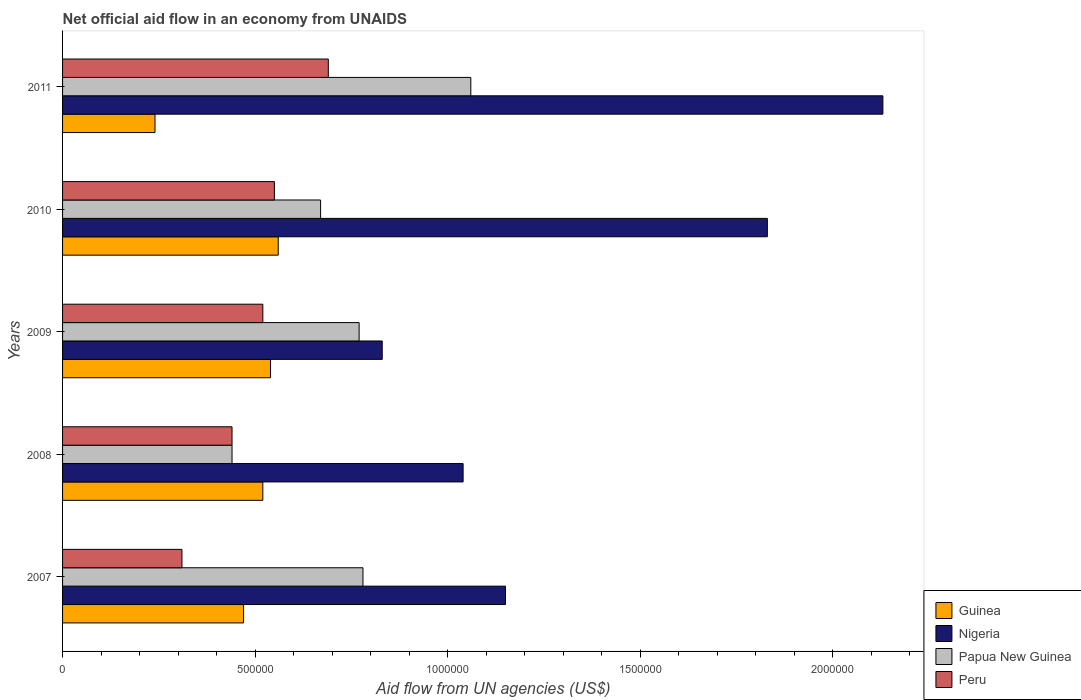How many different coloured bars are there?
Offer a terse response. 4. How many groups of bars are there?
Give a very brief answer. 5. How many bars are there on the 2nd tick from the top?
Provide a succinct answer. 4. In how many cases, is the number of bars for a given year not equal to the number of legend labels?
Provide a succinct answer. 0. What is the net official aid flow in Papua New Guinea in 2009?
Your answer should be very brief. 7.70e+05. Across all years, what is the maximum net official aid flow in Papua New Guinea?
Ensure brevity in your answer.  1.06e+06. Across all years, what is the minimum net official aid flow in Nigeria?
Your answer should be very brief. 8.30e+05. In which year was the net official aid flow in Peru maximum?
Offer a terse response. 2011. What is the total net official aid flow in Nigeria in the graph?
Give a very brief answer. 6.98e+06. What is the difference between the net official aid flow in Papua New Guinea in 2008 and that in 2010?
Provide a short and direct response. -2.30e+05. What is the difference between the net official aid flow in Nigeria in 2010 and the net official aid flow in Peru in 2011?
Keep it short and to the point. 1.14e+06. What is the average net official aid flow in Guinea per year?
Your answer should be compact. 4.66e+05. In the year 2008, what is the difference between the net official aid flow in Papua New Guinea and net official aid flow in Guinea?
Provide a short and direct response. -8.00e+04. In how many years, is the net official aid flow in Guinea greater than 200000 US$?
Your response must be concise. 5. What is the ratio of the net official aid flow in Papua New Guinea in 2008 to that in 2009?
Ensure brevity in your answer.  0.57. Is the net official aid flow in Peru in 2007 less than that in 2009?
Provide a short and direct response. Yes. Is the difference between the net official aid flow in Papua New Guinea in 2007 and 2010 greater than the difference between the net official aid flow in Guinea in 2007 and 2010?
Your response must be concise. Yes. What is the difference between the highest and the second highest net official aid flow in Guinea?
Provide a short and direct response. 2.00e+04. What is the difference between the highest and the lowest net official aid flow in Guinea?
Your answer should be compact. 3.20e+05. Is the sum of the net official aid flow in Nigeria in 2009 and 2011 greater than the maximum net official aid flow in Peru across all years?
Make the answer very short. Yes. What does the 4th bar from the top in 2009 represents?
Ensure brevity in your answer.  Guinea. What does the 2nd bar from the bottom in 2010 represents?
Your answer should be very brief. Nigeria. Is it the case that in every year, the sum of the net official aid flow in Guinea and net official aid flow in Peru is greater than the net official aid flow in Nigeria?
Your answer should be compact. No. How many bars are there?
Give a very brief answer. 20. Are all the bars in the graph horizontal?
Your response must be concise. Yes. What is the difference between two consecutive major ticks on the X-axis?
Provide a succinct answer. 5.00e+05. Where does the legend appear in the graph?
Your answer should be compact. Bottom right. How many legend labels are there?
Ensure brevity in your answer.  4. What is the title of the graph?
Offer a very short reply. Net official aid flow in an economy from UNAIDS. Does "Syrian Arab Republic" appear as one of the legend labels in the graph?
Offer a terse response. No. What is the label or title of the X-axis?
Make the answer very short. Aid flow from UN agencies (US$). What is the label or title of the Y-axis?
Give a very brief answer. Years. What is the Aid flow from UN agencies (US$) in Nigeria in 2007?
Keep it short and to the point. 1.15e+06. What is the Aid flow from UN agencies (US$) of Papua New Guinea in 2007?
Make the answer very short. 7.80e+05. What is the Aid flow from UN agencies (US$) of Guinea in 2008?
Offer a terse response. 5.20e+05. What is the Aid flow from UN agencies (US$) of Nigeria in 2008?
Your response must be concise. 1.04e+06. What is the Aid flow from UN agencies (US$) in Papua New Guinea in 2008?
Your answer should be very brief. 4.40e+05. What is the Aid flow from UN agencies (US$) of Peru in 2008?
Provide a short and direct response. 4.40e+05. What is the Aid flow from UN agencies (US$) of Guinea in 2009?
Ensure brevity in your answer.  5.40e+05. What is the Aid flow from UN agencies (US$) of Nigeria in 2009?
Offer a terse response. 8.30e+05. What is the Aid flow from UN agencies (US$) in Papua New Guinea in 2009?
Give a very brief answer. 7.70e+05. What is the Aid flow from UN agencies (US$) of Peru in 2009?
Your answer should be compact. 5.20e+05. What is the Aid flow from UN agencies (US$) of Guinea in 2010?
Provide a succinct answer. 5.60e+05. What is the Aid flow from UN agencies (US$) of Nigeria in 2010?
Your response must be concise. 1.83e+06. What is the Aid flow from UN agencies (US$) in Papua New Guinea in 2010?
Make the answer very short. 6.70e+05. What is the Aid flow from UN agencies (US$) of Nigeria in 2011?
Your answer should be compact. 2.13e+06. What is the Aid flow from UN agencies (US$) in Papua New Guinea in 2011?
Your response must be concise. 1.06e+06. What is the Aid flow from UN agencies (US$) in Peru in 2011?
Provide a succinct answer. 6.90e+05. Across all years, what is the maximum Aid flow from UN agencies (US$) in Guinea?
Give a very brief answer. 5.60e+05. Across all years, what is the maximum Aid flow from UN agencies (US$) in Nigeria?
Keep it short and to the point. 2.13e+06. Across all years, what is the maximum Aid flow from UN agencies (US$) in Papua New Guinea?
Your answer should be compact. 1.06e+06. Across all years, what is the maximum Aid flow from UN agencies (US$) in Peru?
Ensure brevity in your answer.  6.90e+05. Across all years, what is the minimum Aid flow from UN agencies (US$) in Guinea?
Offer a very short reply. 2.40e+05. Across all years, what is the minimum Aid flow from UN agencies (US$) of Nigeria?
Give a very brief answer. 8.30e+05. What is the total Aid flow from UN agencies (US$) of Guinea in the graph?
Keep it short and to the point. 2.33e+06. What is the total Aid flow from UN agencies (US$) of Nigeria in the graph?
Give a very brief answer. 6.98e+06. What is the total Aid flow from UN agencies (US$) in Papua New Guinea in the graph?
Make the answer very short. 3.72e+06. What is the total Aid flow from UN agencies (US$) of Peru in the graph?
Offer a terse response. 2.51e+06. What is the difference between the Aid flow from UN agencies (US$) of Nigeria in 2007 and that in 2008?
Keep it short and to the point. 1.10e+05. What is the difference between the Aid flow from UN agencies (US$) in Papua New Guinea in 2007 and that in 2008?
Keep it short and to the point. 3.40e+05. What is the difference between the Aid flow from UN agencies (US$) in Nigeria in 2007 and that in 2009?
Make the answer very short. 3.20e+05. What is the difference between the Aid flow from UN agencies (US$) in Peru in 2007 and that in 2009?
Your response must be concise. -2.10e+05. What is the difference between the Aid flow from UN agencies (US$) in Guinea in 2007 and that in 2010?
Keep it short and to the point. -9.00e+04. What is the difference between the Aid flow from UN agencies (US$) in Nigeria in 2007 and that in 2010?
Offer a very short reply. -6.80e+05. What is the difference between the Aid flow from UN agencies (US$) in Papua New Guinea in 2007 and that in 2010?
Provide a short and direct response. 1.10e+05. What is the difference between the Aid flow from UN agencies (US$) of Nigeria in 2007 and that in 2011?
Your answer should be compact. -9.80e+05. What is the difference between the Aid flow from UN agencies (US$) in Papua New Guinea in 2007 and that in 2011?
Ensure brevity in your answer.  -2.80e+05. What is the difference between the Aid flow from UN agencies (US$) of Peru in 2007 and that in 2011?
Ensure brevity in your answer.  -3.80e+05. What is the difference between the Aid flow from UN agencies (US$) of Guinea in 2008 and that in 2009?
Give a very brief answer. -2.00e+04. What is the difference between the Aid flow from UN agencies (US$) in Nigeria in 2008 and that in 2009?
Provide a succinct answer. 2.10e+05. What is the difference between the Aid flow from UN agencies (US$) in Papua New Guinea in 2008 and that in 2009?
Your answer should be very brief. -3.30e+05. What is the difference between the Aid flow from UN agencies (US$) in Guinea in 2008 and that in 2010?
Provide a short and direct response. -4.00e+04. What is the difference between the Aid flow from UN agencies (US$) in Nigeria in 2008 and that in 2010?
Ensure brevity in your answer.  -7.90e+05. What is the difference between the Aid flow from UN agencies (US$) in Nigeria in 2008 and that in 2011?
Ensure brevity in your answer.  -1.09e+06. What is the difference between the Aid flow from UN agencies (US$) of Papua New Guinea in 2008 and that in 2011?
Provide a succinct answer. -6.20e+05. What is the difference between the Aid flow from UN agencies (US$) of Guinea in 2009 and that in 2010?
Provide a succinct answer. -2.00e+04. What is the difference between the Aid flow from UN agencies (US$) of Nigeria in 2009 and that in 2010?
Your answer should be very brief. -1.00e+06. What is the difference between the Aid flow from UN agencies (US$) of Nigeria in 2009 and that in 2011?
Keep it short and to the point. -1.30e+06. What is the difference between the Aid flow from UN agencies (US$) of Papua New Guinea in 2009 and that in 2011?
Offer a very short reply. -2.90e+05. What is the difference between the Aid flow from UN agencies (US$) of Peru in 2009 and that in 2011?
Keep it short and to the point. -1.70e+05. What is the difference between the Aid flow from UN agencies (US$) in Guinea in 2010 and that in 2011?
Your answer should be very brief. 3.20e+05. What is the difference between the Aid flow from UN agencies (US$) in Papua New Guinea in 2010 and that in 2011?
Offer a terse response. -3.90e+05. What is the difference between the Aid flow from UN agencies (US$) of Guinea in 2007 and the Aid flow from UN agencies (US$) of Nigeria in 2008?
Provide a short and direct response. -5.70e+05. What is the difference between the Aid flow from UN agencies (US$) of Guinea in 2007 and the Aid flow from UN agencies (US$) of Papua New Guinea in 2008?
Provide a short and direct response. 3.00e+04. What is the difference between the Aid flow from UN agencies (US$) of Nigeria in 2007 and the Aid flow from UN agencies (US$) of Papua New Guinea in 2008?
Your answer should be compact. 7.10e+05. What is the difference between the Aid flow from UN agencies (US$) in Nigeria in 2007 and the Aid flow from UN agencies (US$) in Peru in 2008?
Your answer should be very brief. 7.10e+05. What is the difference between the Aid flow from UN agencies (US$) of Guinea in 2007 and the Aid flow from UN agencies (US$) of Nigeria in 2009?
Ensure brevity in your answer.  -3.60e+05. What is the difference between the Aid flow from UN agencies (US$) of Guinea in 2007 and the Aid flow from UN agencies (US$) of Papua New Guinea in 2009?
Give a very brief answer. -3.00e+05. What is the difference between the Aid flow from UN agencies (US$) of Guinea in 2007 and the Aid flow from UN agencies (US$) of Peru in 2009?
Make the answer very short. -5.00e+04. What is the difference between the Aid flow from UN agencies (US$) in Nigeria in 2007 and the Aid flow from UN agencies (US$) in Papua New Guinea in 2009?
Offer a very short reply. 3.80e+05. What is the difference between the Aid flow from UN agencies (US$) of Nigeria in 2007 and the Aid flow from UN agencies (US$) of Peru in 2009?
Give a very brief answer. 6.30e+05. What is the difference between the Aid flow from UN agencies (US$) in Guinea in 2007 and the Aid flow from UN agencies (US$) in Nigeria in 2010?
Offer a very short reply. -1.36e+06. What is the difference between the Aid flow from UN agencies (US$) in Guinea in 2007 and the Aid flow from UN agencies (US$) in Peru in 2010?
Keep it short and to the point. -8.00e+04. What is the difference between the Aid flow from UN agencies (US$) in Nigeria in 2007 and the Aid flow from UN agencies (US$) in Peru in 2010?
Give a very brief answer. 6.00e+05. What is the difference between the Aid flow from UN agencies (US$) of Guinea in 2007 and the Aid flow from UN agencies (US$) of Nigeria in 2011?
Your answer should be very brief. -1.66e+06. What is the difference between the Aid flow from UN agencies (US$) of Guinea in 2007 and the Aid flow from UN agencies (US$) of Papua New Guinea in 2011?
Ensure brevity in your answer.  -5.90e+05. What is the difference between the Aid flow from UN agencies (US$) of Guinea in 2007 and the Aid flow from UN agencies (US$) of Peru in 2011?
Give a very brief answer. -2.20e+05. What is the difference between the Aid flow from UN agencies (US$) in Guinea in 2008 and the Aid flow from UN agencies (US$) in Nigeria in 2009?
Keep it short and to the point. -3.10e+05. What is the difference between the Aid flow from UN agencies (US$) of Nigeria in 2008 and the Aid flow from UN agencies (US$) of Peru in 2009?
Give a very brief answer. 5.20e+05. What is the difference between the Aid flow from UN agencies (US$) in Papua New Guinea in 2008 and the Aid flow from UN agencies (US$) in Peru in 2009?
Give a very brief answer. -8.00e+04. What is the difference between the Aid flow from UN agencies (US$) of Guinea in 2008 and the Aid flow from UN agencies (US$) of Nigeria in 2010?
Give a very brief answer. -1.31e+06. What is the difference between the Aid flow from UN agencies (US$) of Nigeria in 2008 and the Aid flow from UN agencies (US$) of Peru in 2010?
Offer a very short reply. 4.90e+05. What is the difference between the Aid flow from UN agencies (US$) in Papua New Guinea in 2008 and the Aid flow from UN agencies (US$) in Peru in 2010?
Give a very brief answer. -1.10e+05. What is the difference between the Aid flow from UN agencies (US$) in Guinea in 2008 and the Aid flow from UN agencies (US$) in Nigeria in 2011?
Give a very brief answer. -1.61e+06. What is the difference between the Aid flow from UN agencies (US$) of Guinea in 2008 and the Aid flow from UN agencies (US$) of Papua New Guinea in 2011?
Make the answer very short. -5.40e+05. What is the difference between the Aid flow from UN agencies (US$) in Nigeria in 2008 and the Aid flow from UN agencies (US$) in Papua New Guinea in 2011?
Ensure brevity in your answer.  -2.00e+04. What is the difference between the Aid flow from UN agencies (US$) of Guinea in 2009 and the Aid flow from UN agencies (US$) of Nigeria in 2010?
Provide a short and direct response. -1.29e+06. What is the difference between the Aid flow from UN agencies (US$) in Guinea in 2009 and the Aid flow from UN agencies (US$) in Papua New Guinea in 2010?
Offer a very short reply. -1.30e+05. What is the difference between the Aid flow from UN agencies (US$) of Guinea in 2009 and the Aid flow from UN agencies (US$) of Peru in 2010?
Make the answer very short. -10000. What is the difference between the Aid flow from UN agencies (US$) of Nigeria in 2009 and the Aid flow from UN agencies (US$) of Peru in 2010?
Give a very brief answer. 2.80e+05. What is the difference between the Aid flow from UN agencies (US$) in Guinea in 2009 and the Aid flow from UN agencies (US$) in Nigeria in 2011?
Give a very brief answer. -1.59e+06. What is the difference between the Aid flow from UN agencies (US$) in Guinea in 2009 and the Aid flow from UN agencies (US$) in Papua New Guinea in 2011?
Offer a terse response. -5.20e+05. What is the difference between the Aid flow from UN agencies (US$) in Guinea in 2010 and the Aid flow from UN agencies (US$) in Nigeria in 2011?
Provide a short and direct response. -1.57e+06. What is the difference between the Aid flow from UN agencies (US$) in Guinea in 2010 and the Aid flow from UN agencies (US$) in Papua New Guinea in 2011?
Your answer should be compact. -5.00e+05. What is the difference between the Aid flow from UN agencies (US$) in Nigeria in 2010 and the Aid flow from UN agencies (US$) in Papua New Guinea in 2011?
Offer a very short reply. 7.70e+05. What is the difference between the Aid flow from UN agencies (US$) of Nigeria in 2010 and the Aid flow from UN agencies (US$) of Peru in 2011?
Your answer should be compact. 1.14e+06. What is the difference between the Aid flow from UN agencies (US$) in Papua New Guinea in 2010 and the Aid flow from UN agencies (US$) in Peru in 2011?
Make the answer very short. -2.00e+04. What is the average Aid flow from UN agencies (US$) in Guinea per year?
Your answer should be compact. 4.66e+05. What is the average Aid flow from UN agencies (US$) of Nigeria per year?
Provide a succinct answer. 1.40e+06. What is the average Aid flow from UN agencies (US$) in Papua New Guinea per year?
Give a very brief answer. 7.44e+05. What is the average Aid flow from UN agencies (US$) in Peru per year?
Offer a very short reply. 5.02e+05. In the year 2007, what is the difference between the Aid flow from UN agencies (US$) of Guinea and Aid flow from UN agencies (US$) of Nigeria?
Your answer should be compact. -6.80e+05. In the year 2007, what is the difference between the Aid flow from UN agencies (US$) in Guinea and Aid flow from UN agencies (US$) in Papua New Guinea?
Offer a terse response. -3.10e+05. In the year 2007, what is the difference between the Aid flow from UN agencies (US$) in Nigeria and Aid flow from UN agencies (US$) in Papua New Guinea?
Give a very brief answer. 3.70e+05. In the year 2007, what is the difference between the Aid flow from UN agencies (US$) in Nigeria and Aid flow from UN agencies (US$) in Peru?
Offer a very short reply. 8.40e+05. In the year 2008, what is the difference between the Aid flow from UN agencies (US$) in Guinea and Aid flow from UN agencies (US$) in Nigeria?
Make the answer very short. -5.20e+05. In the year 2008, what is the difference between the Aid flow from UN agencies (US$) in Guinea and Aid flow from UN agencies (US$) in Peru?
Make the answer very short. 8.00e+04. In the year 2009, what is the difference between the Aid flow from UN agencies (US$) in Guinea and Aid flow from UN agencies (US$) in Papua New Guinea?
Give a very brief answer. -2.30e+05. In the year 2009, what is the difference between the Aid flow from UN agencies (US$) of Nigeria and Aid flow from UN agencies (US$) of Papua New Guinea?
Offer a terse response. 6.00e+04. In the year 2009, what is the difference between the Aid flow from UN agencies (US$) in Nigeria and Aid flow from UN agencies (US$) in Peru?
Provide a succinct answer. 3.10e+05. In the year 2009, what is the difference between the Aid flow from UN agencies (US$) of Papua New Guinea and Aid flow from UN agencies (US$) of Peru?
Make the answer very short. 2.50e+05. In the year 2010, what is the difference between the Aid flow from UN agencies (US$) of Guinea and Aid flow from UN agencies (US$) of Nigeria?
Provide a short and direct response. -1.27e+06. In the year 2010, what is the difference between the Aid flow from UN agencies (US$) in Guinea and Aid flow from UN agencies (US$) in Papua New Guinea?
Offer a terse response. -1.10e+05. In the year 2010, what is the difference between the Aid flow from UN agencies (US$) in Guinea and Aid flow from UN agencies (US$) in Peru?
Give a very brief answer. 10000. In the year 2010, what is the difference between the Aid flow from UN agencies (US$) in Nigeria and Aid flow from UN agencies (US$) in Papua New Guinea?
Your answer should be compact. 1.16e+06. In the year 2010, what is the difference between the Aid flow from UN agencies (US$) in Nigeria and Aid flow from UN agencies (US$) in Peru?
Provide a succinct answer. 1.28e+06. In the year 2010, what is the difference between the Aid flow from UN agencies (US$) of Papua New Guinea and Aid flow from UN agencies (US$) of Peru?
Your answer should be very brief. 1.20e+05. In the year 2011, what is the difference between the Aid flow from UN agencies (US$) of Guinea and Aid flow from UN agencies (US$) of Nigeria?
Your response must be concise. -1.89e+06. In the year 2011, what is the difference between the Aid flow from UN agencies (US$) in Guinea and Aid flow from UN agencies (US$) in Papua New Guinea?
Give a very brief answer. -8.20e+05. In the year 2011, what is the difference between the Aid flow from UN agencies (US$) in Guinea and Aid flow from UN agencies (US$) in Peru?
Your answer should be very brief. -4.50e+05. In the year 2011, what is the difference between the Aid flow from UN agencies (US$) in Nigeria and Aid flow from UN agencies (US$) in Papua New Guinea?
Ensure brevity in your answer.  1.07e+06. In the year 2011, what is the difference between the Aid flow from UN agencies (US$) in Nigeria and Aid flow from UN agencies (US$) in Peru?
Your answer should be very brief. 1.44e+06. What is the ratio of the Aid flow from UN agencies (US$) of Guinea in 2007 to that in 2008?
Offer a terse response. 0.9. What is the ratio of the Aid flow from UN agencies (US$) of Nigeria in 2007 to that in 2008?
Provide a succinct answer. 1.11. What is the ratio of the Aid flow from UN agencies (US$) of Papua New Guinea in 2007 to that in 2008?
Give a very brief answer. 1.77. What is the ratio of the Aid flow from UN agencies (US$) in Peru in 2007 to that in 2008?
Your answer should be compact. 0.7. What is the ratio of the Aid flow from UN agencies (US$) in Guinea in 2007 to that in 2009?
Offer a terse response. 0.87. What is the ratio of the Aid flow from UN agencies (US$) of Nigeria in 2007 to that in 2009?
Give a very brief answer. 1.39. What is the ratio of the Aid flow from UN agencies (US$) of Peru in 2007 to that in 2009?
Your response must be concise. 0.6. What is the ratio of the Aid flow from UN agencies (US$) of Guinea in 2007 to that in 2010?
Provide a succinct answer. 0.84. What is the ratio of the Aid flow from UN agencies (US$) of Nigeria in 2007 to that in 2010?
Provide a short and direct response. 0.63. What is the ratio of the Aid flow from UN agencies (US$) of Papua New Guinea in 2007 to that in 2010?
Your answer should be compact. 1.16. What is the ratio of the Aid flow from UN agencies (US$) in Peru in 2007 to that in 2010?
Your answer should be very brief. 0.56. What is the ratio of the Aid flow from UN agencies (US$) in Guinea in 2007 to that in 2011?
Offer a very short reply. 1.96. What is the ratio of the Aid flow from UN agencies (US$) in Nigeria in 2007 to that in 2011?
Give a very brief answer. 0.54. What is the ratio of the Aid flow from UN agencies (US$) of Papua New Guinea in 2007 to that in 2011?
Offer a terse response. 0.74. What is the ratio of the Aid flow from UN agencies (US$) in Peru in 2007 to that in 2011?
Give a very brief answer. 0.45. What is the ratio of the Aid flow from UN agencies (US$) of Nigeria in 2008 to that in 2009?
Provide a short and direct response. 1.25. What is the ratio of the Aid flow from UN agencies (US$) of Papua New Guinea in 2008 to that in 2009?
Offer a very short reply. 0.57. What is the ratio of the Aid flow from UN agencies (US$) in Peru in 2008 to that in 2009?
Give a very brief answer. 0.85. What is the ratio of the Aid flow from UN agencies (US$) in Nigeria in 2008 to that in 2010?
Give a very brief answer. 0.57. What is the ratio of the Aid flow from UN agencies (US$) of Papua New Guinea in 2008 to that in 2010?
Provide a short and direct response. 0.66. What is the ratio of the Aid flow from UN agencies (US$) of Peru in 2008 to that in 2010?
Your response must be concise. 0.8. What is the ratio of the Aid flow from UN agencies (US$) of Guinea in 2008 to that in 2011?
Offer a terse response. 2.17. What is the ratio of the Aid flow from UN agencies (US$) in Nigeria in 2008 to that in 2011?
Offer a terse response. 0.49. What is the ratio of the Aid flow from UN agencies (US$) in Papua New Guinea in 2008 to that in 2011?
Offer a terse response. 0.42. What is the ratio of the Aid flow from UN agencies (US$) of Peru in 2008 to that in 2011?
Ensure brevity in your answer.  0.64. What is the ratio of the Aid flow from UN agencies (US$) of Guinea in 2009 to that in 2010?
Keep it short and to the point. 0.96. What is the ratio of the Aid flow from UN agencies (US$) of Nigeria in 2009 to that in 2010?
Give a very brief answer. 0.45. What is the ratio of the Aid flow from UN agencies (US$) of Papua New Guinea in 2009 to that in 2010?
Your answer should be compact. 1.15. What is the ratio of the Aid flow from UN agencies (US$) of Peru in 2009 to that in 2010?
Your answer should be compact. 0.95. What is the ratio of the Aid flow from UN agencies (US$) of Guinea in 2009 to that in 2011?
Your answer should be compact. 2.25. What is the ratio of the Aid flow from UN agencies (US$) of Nigeria in 2009 to that in 2011?
Offer a terse response. 0.39. What is the ratio of the Aid flow from UN agencies (US$) in Papua New Guinea in 2009 to that in 2011?
Keep it short and to the point. 0.73. What is the ratio of the Aid flow from UN agencies (US$) in Peru in 2009 to that in 2011?
Offer a very short reply. 0.75. What is the ratio of the Aid flow from UN agencies (US$) of Guinea in 2010 to that in 2011?
Offer a very short reply. 2.33. What is the ratio of the Aid flow from UN agencies (US$) in Nigeria in 2010 to that in 2011?
Make the answer very short. 0.86. What is the ratio of the Aid flow from UN agencies (US$) in Papua New Guinea in 2010 to that in 2011?
Provide a short and direct response. 0.63. What is the ratio of the Aid flow from UN agencies (US$) of Peru in 2010 to that in 2011?
Your answer should be very brief. 0.8. What is the difference between the highest and the second highest Aid flow from UN agencies (US$) of Nigeria?
Provide a succinct answer. 3.00e+05. What is the difference between the highest and the second highest Aid flow from UN agencies (US$) of Papua New Guinea?
Your response must be concise. 2.80e+05. What is the difference between the highest and the lowest Aid flow from UN agencies (US$) of Nigeria?
Ensure brevity in your answer.  1.30e+06. What is the difference between the highest and the lowest Aid flow from UN agencies (US$) in Papua New Guinea?
Your answer should be very brief. 6.20e+05. What is the difference between the highest and the lowest Aid flow from UN agencies (US$) in Peru?
Keep it short and to the point. 3.80e+05. 